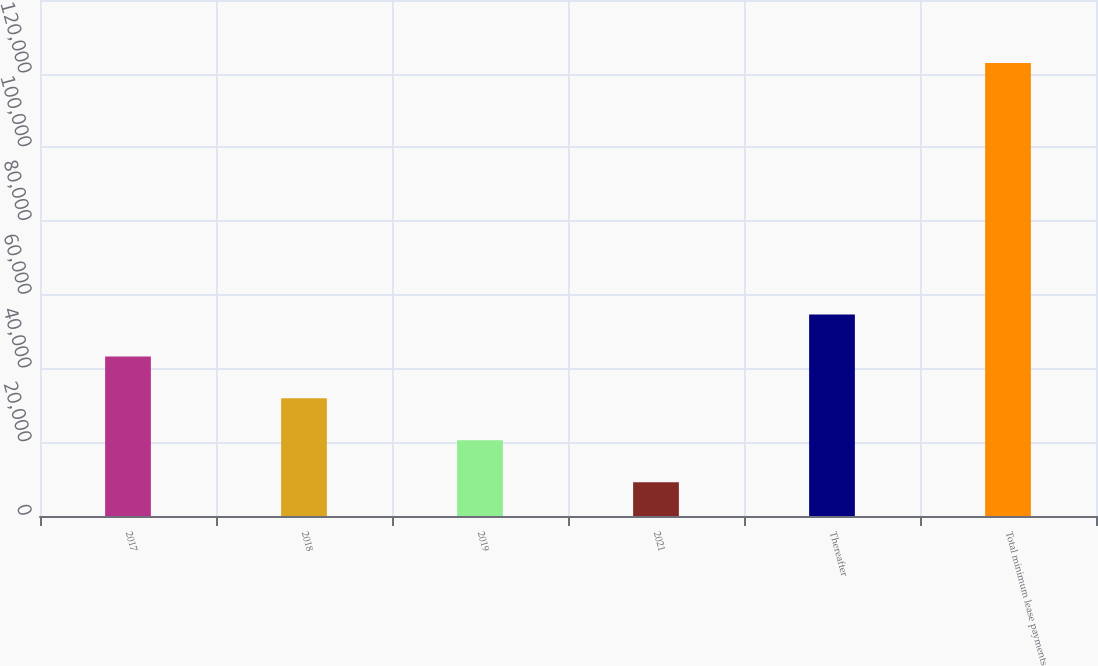Convert chart to OTSL. <chart><loc_0><loc_0><loc_500><loc_500><bar_chart><fcel>2017<fcel>2018<fcel>2019<fcel>2021<fcel>Thereafter<fcel>Total minimum lease payments<nl><fcel>43308.8<fcel>31935.2<fcel>20561.6<fcel>9188<fcel>54682.4<fcel>122924<nl></chart> 